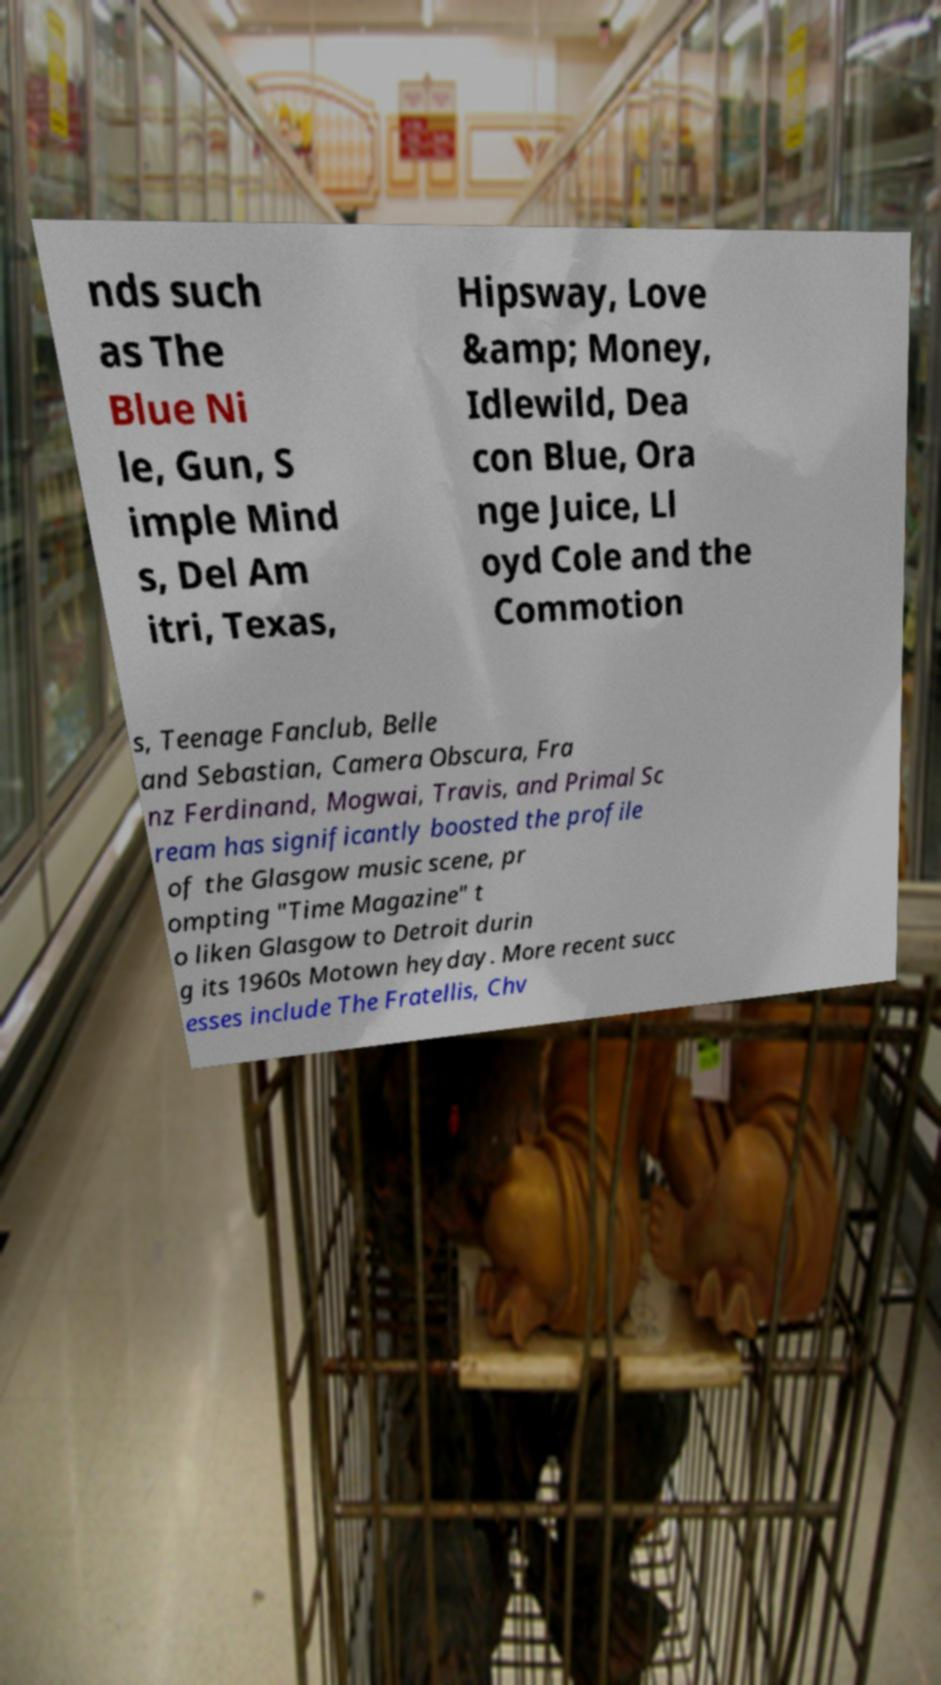Can you accurately transcribe the text from the provided image for me? nds such as The Blue Ni le, Gun, S imple Mind s, Del Am itri, Texas, Hipsway, Love &amp; Money, Idlewild, Dea con Blue, Ora nge Juice, Ll oyd Cole and the Commotion s, Teenage Fanclub, Belle and Sebastian, Camera Obscura, Fra nz Ferdinand, Mogwai, Travis, and Primal Sc ream has significantly boosted the profile of the Glasgow music scene, pr ompting "Time Magazine" t o liken Glasgow to Detroit durin g its 1960s Motown heyday. More recent succ esses include The Fratellis, Chv 